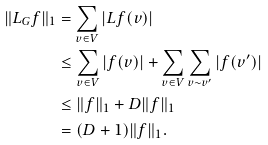<formula> <loc_0><loc_0><loc_500><loc_500>\| L _ { G } f \| _ { 1 } & = \sum _ { v \in V } | L f ( v ) | \\ & \leq \sum _ { v \in V } | f ( v ) | + \sum _ { v \in V } \sum _ { v \sim v ^ { \prime } } | f ( v ^ { \prime } ) | \\ & \leq \| f \| _ { 1 } + D \| f \| _ { 1 } \\ & = ( D + 1 ) \| f \| _ { 1 } .</formula> 